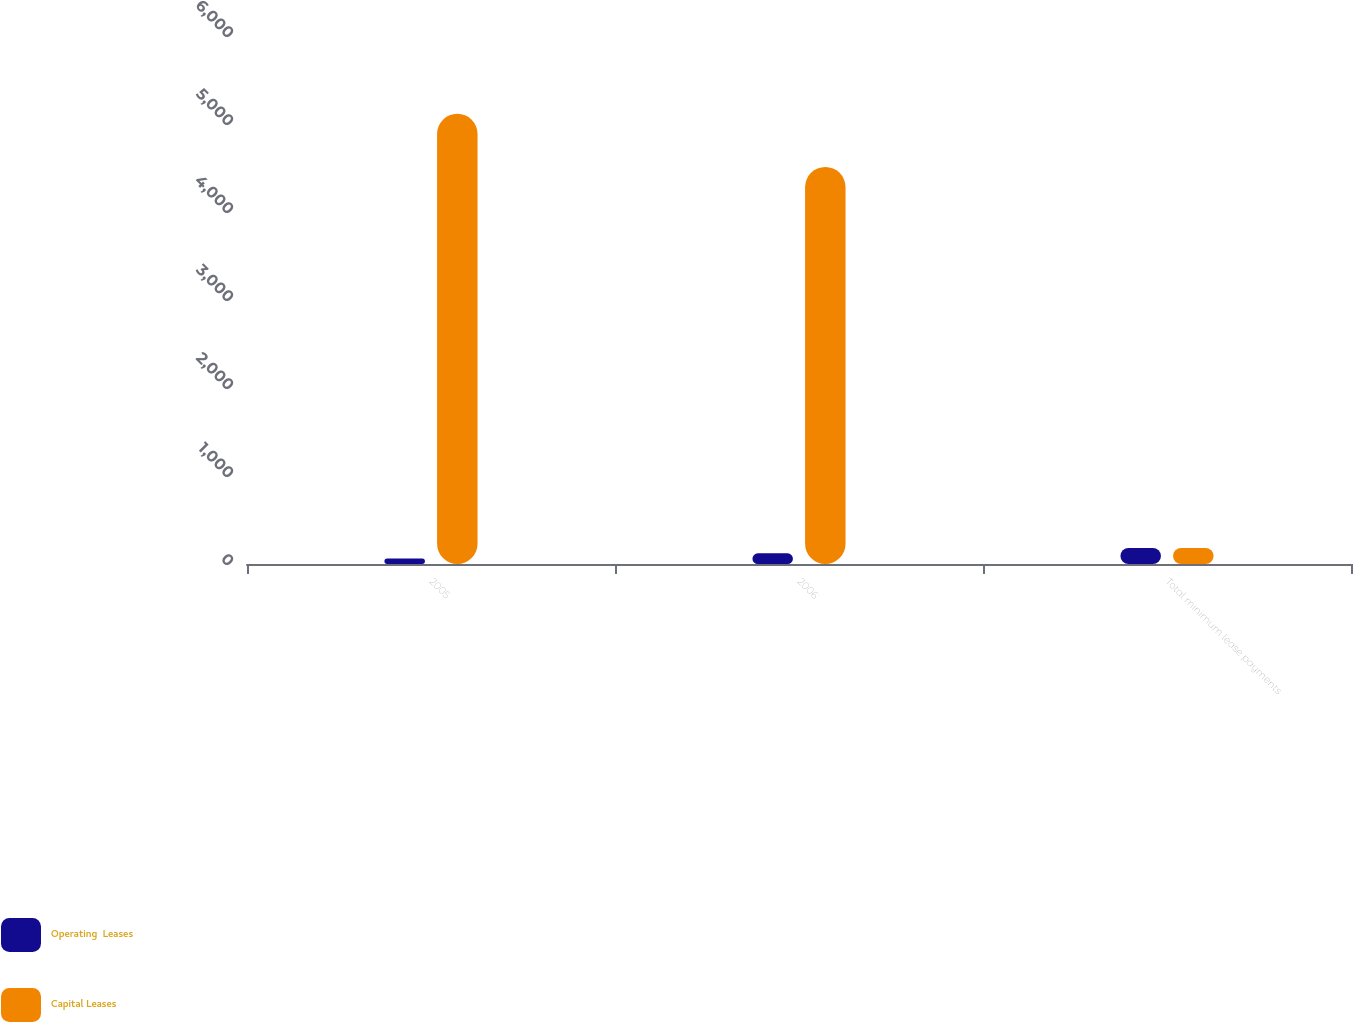<chart> <loc_0><loc_0><loc_500><loc_500><stacked_bar_chart><ecel><fcel>2005<fcel>2006<fcel>Total minimum lease payments<nl><fcel>Operating  Leases<fcel>62<fcel>121<fcel>183<nl><fcel>Capital Leases<fcel>5116<fcel>4512<fcel>183<nl></chart> 